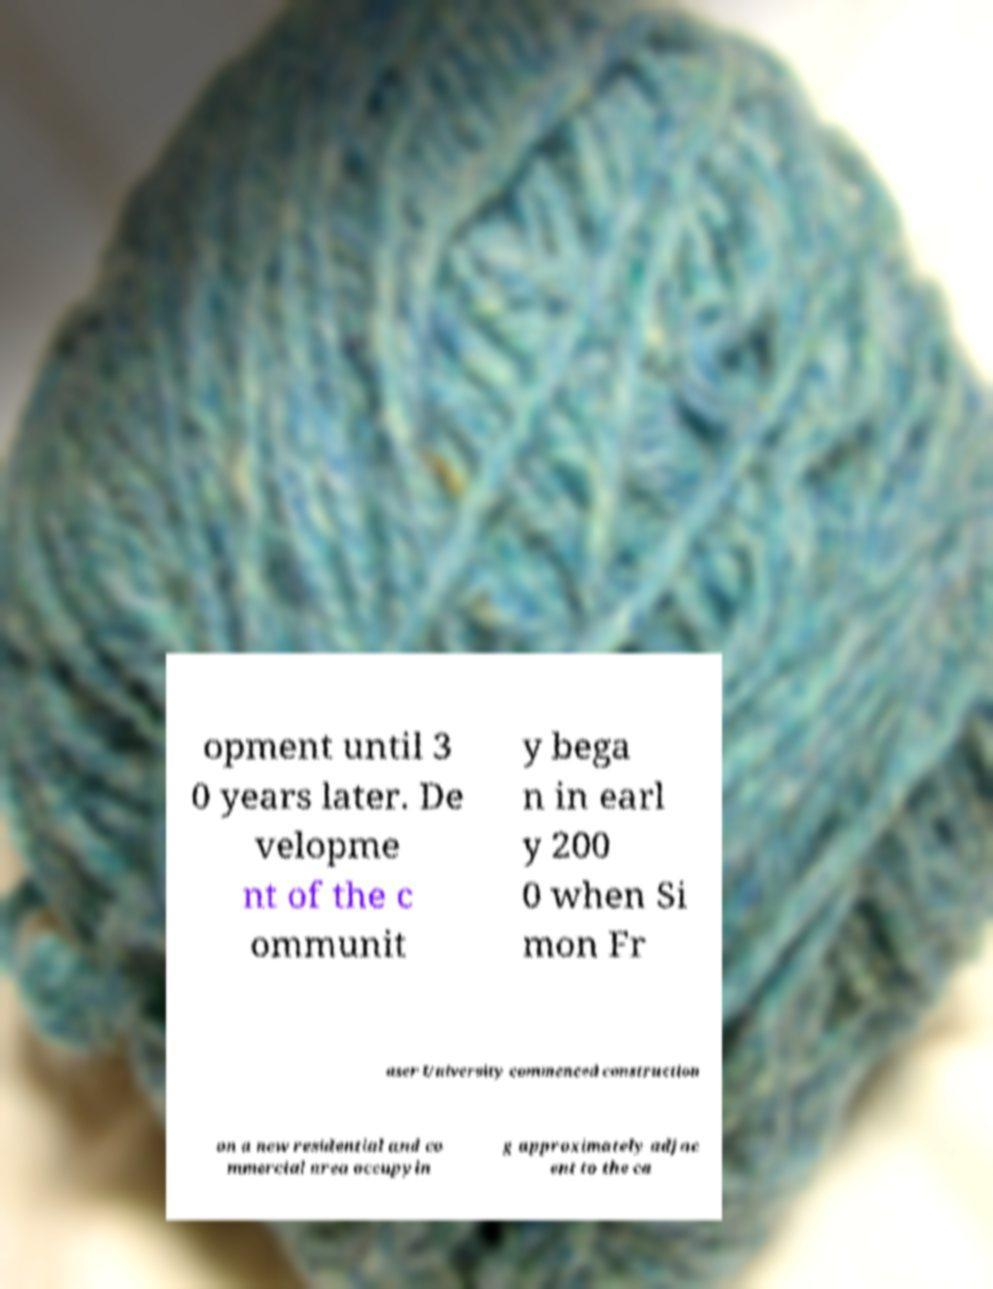For documentation purposes, I need the text within this image transcribed. Could you provide that? opment until 3 0 years later. De velopme nt of the c ommunit y bega n in earl y 200 0 when Si mon Fr aser University commenced construction on a new residential and co mmercial area occupyin g approximately adjac ent to the ca 